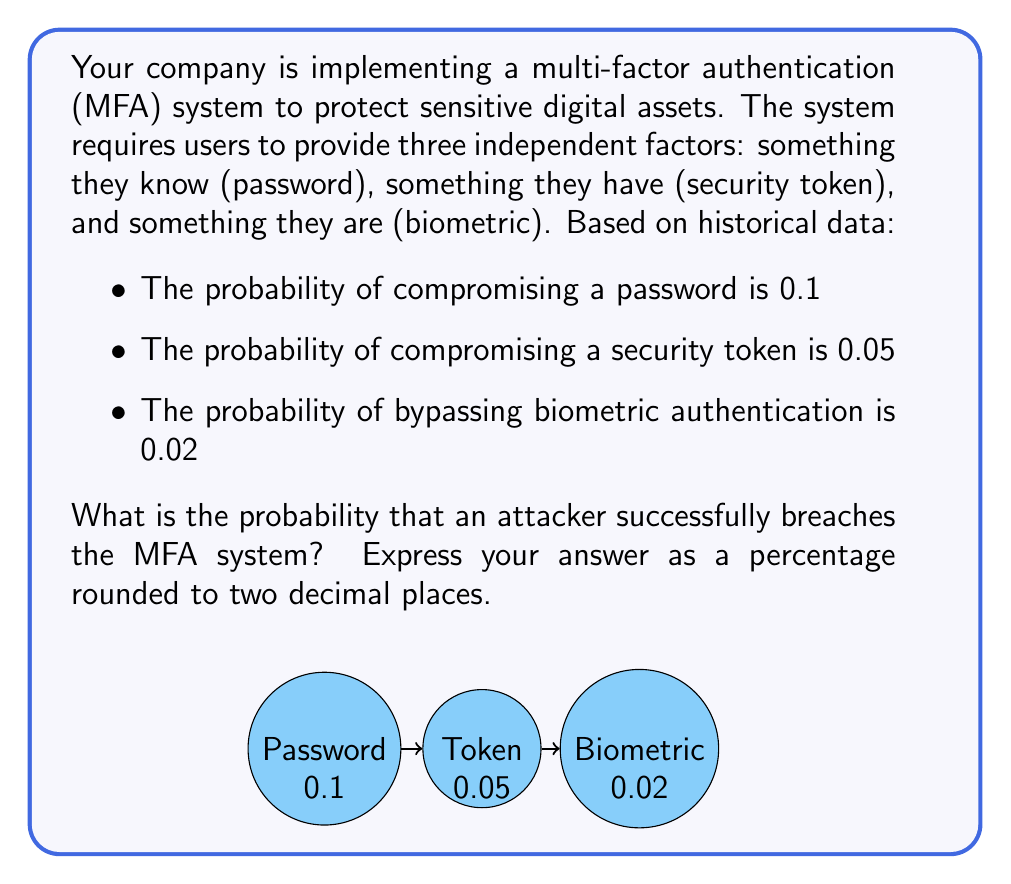What is the answer to this math problem? To solve this problem, we need to use the concept of independent events in probability theory. For an attacker to successfully breach the MFA system, they must compromise all three factors independently. We can calculate this using the multiplication rule of probability for independent events.

Let's define the events:
- A: Successfully compromising the password
- B: Successfully compromising the security token
- C: Successfully bypassing biometric authentication

Given:
P(A) = 0.1
P(B) = 0.05
P(C) = 0.02

The probability of successfully breaching the MFA system is the probability of all three events occurring simultaneously:

P(A and B and C) = P(A) × P(B) × P(C)

Substituting the values:

P(A and B and C) = 0.1 × 0.05 × 0.02

Calculating:
P(A and B and C) = 0.0001

To express this as a percentage:
0.0001 × 100 = 0.01%

Rounding to two decimal places:
0.01%

This extremely low probability demonstrates the effectiveness of multi-factor authentication in protecting digital assets.
Answer: 0.01% 